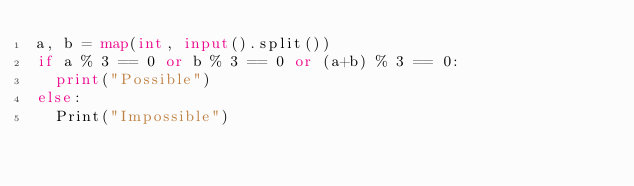Convert code to text. <code><loc_0><loc_0><loc_500><loc_500><_Python_>a, b = map(int, input().split())
if a % 3 == 0 or b % 3 == 0 or (a+b) % 3 == 0:
  print("Possible")
else:
  Print("Impossible")</code> 